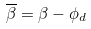Convert formula to latex. <formula><loc_0><loc_0><loc_500><loc_500>\overline { \beta } = \beta - \phi _ { d }</formula> 